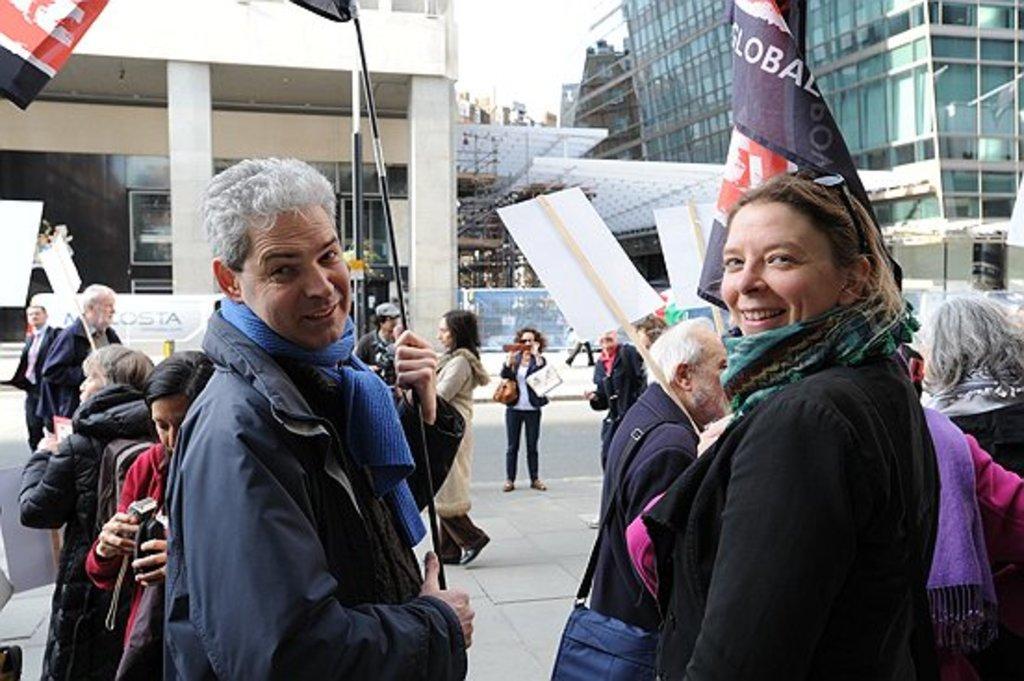In one or two sentences, can you explain what this image depicts? There are many people. Person in the front is wearing a scarf and holding something. In the background there are many buildings with pillars. Some are holding placards. Also there is a road. 